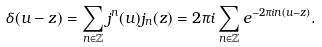Convert formula to latex. <formula><loc_0><loc_0><loc_500><loc_500>\delta ( u - z ) = \sum _ { n \in \mathbb { Z } } j ^ { n } ( u ) j _ { n } ( z ) = 2 \pi i \sum _ { n \in \mathbb { Z } } e ^ { - 2 \pi i n ( u - z ) } .</formula> 